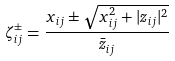Convert formula to latex. <formula><loc_0><loc_0><loc_500><loc_500>\zeta _ { i j } ^ { \pm } = \frac { x _ { i j } \pm \sqrt { x _ { i j } ^ { 2 } + | z _ { i j } | ^ { 2 } } } { \bar { z } _ { i j } }</formula> 